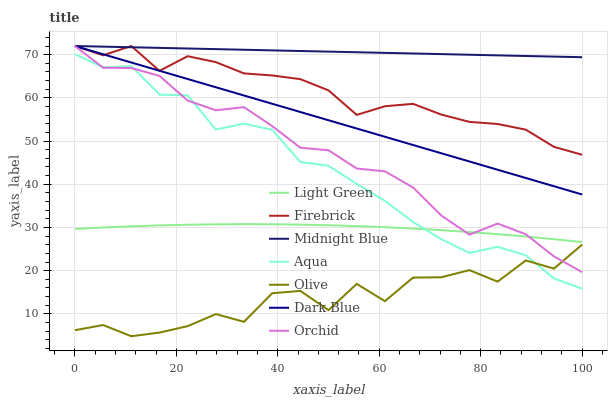Does Olive have the minimum area under the curve?
Answer yes or no. Yes. Does Midnight Blue have the maximum area under the curve?
Answer yes or no. Yes. Does Firebrick have the minimum area under the curve?
Answer yes or no. No. Does Firebrick have the maximum area under the curve?
Answer yes or no. No. Is Dark Blue the smoothest?
Answer yes or no. Yes. Is Olive the roughest?
Answer yes or no. Yes. Is Firebrick the smoothest?
Answer yes or no. No. Is Firebrick the roughest?
Answer yes or no. No. Does Olive have the lowest value?
Answer yes or no. Yes. Does Firebrick have the lowest value?
Answer yes or no. No. Does Orchid have the highest value?
Answer yes or no. Yes. Does Aqua have the highest value?
Answer yes or no. No. Is Light Green less than Firebrick?
Answer yes or no. Yes. Is Firebrick greater than Olive?
Answer yes or no. Yes. Does Light Green intersect Aqua?
Answer yes or no. Yes. Is Light Green less than Aqua?
Answer yes or no. No. Is Light Green greater than Aqua?
Answer yes or no. No. Does Light Green intersect Firebrick?
Answer yes or no. No. 